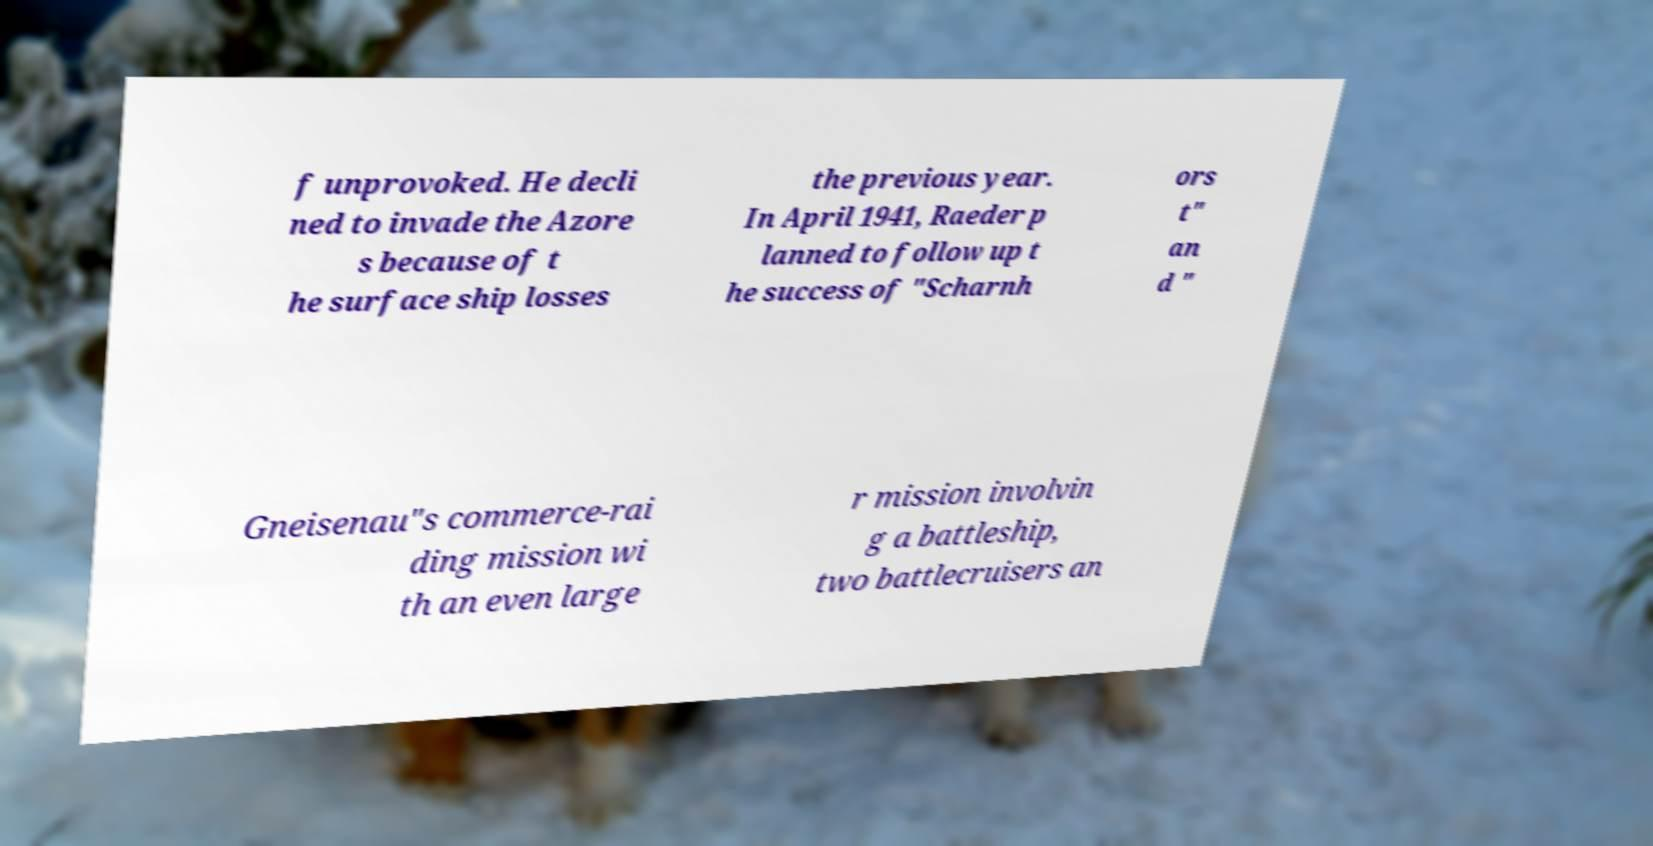Can you accurately transcribe the text from the provided image for me? f unprovoked. He decli ned to invade the Azore s because of t he surface ship losses the previous year. In April 1941, Raeder p lanned to follow up t he success of "Scharnh ors t" an d " Gneisenau"s commerce-rai ding mission wi th an even large r mission involvin g a battleship, two battlecruisers an 